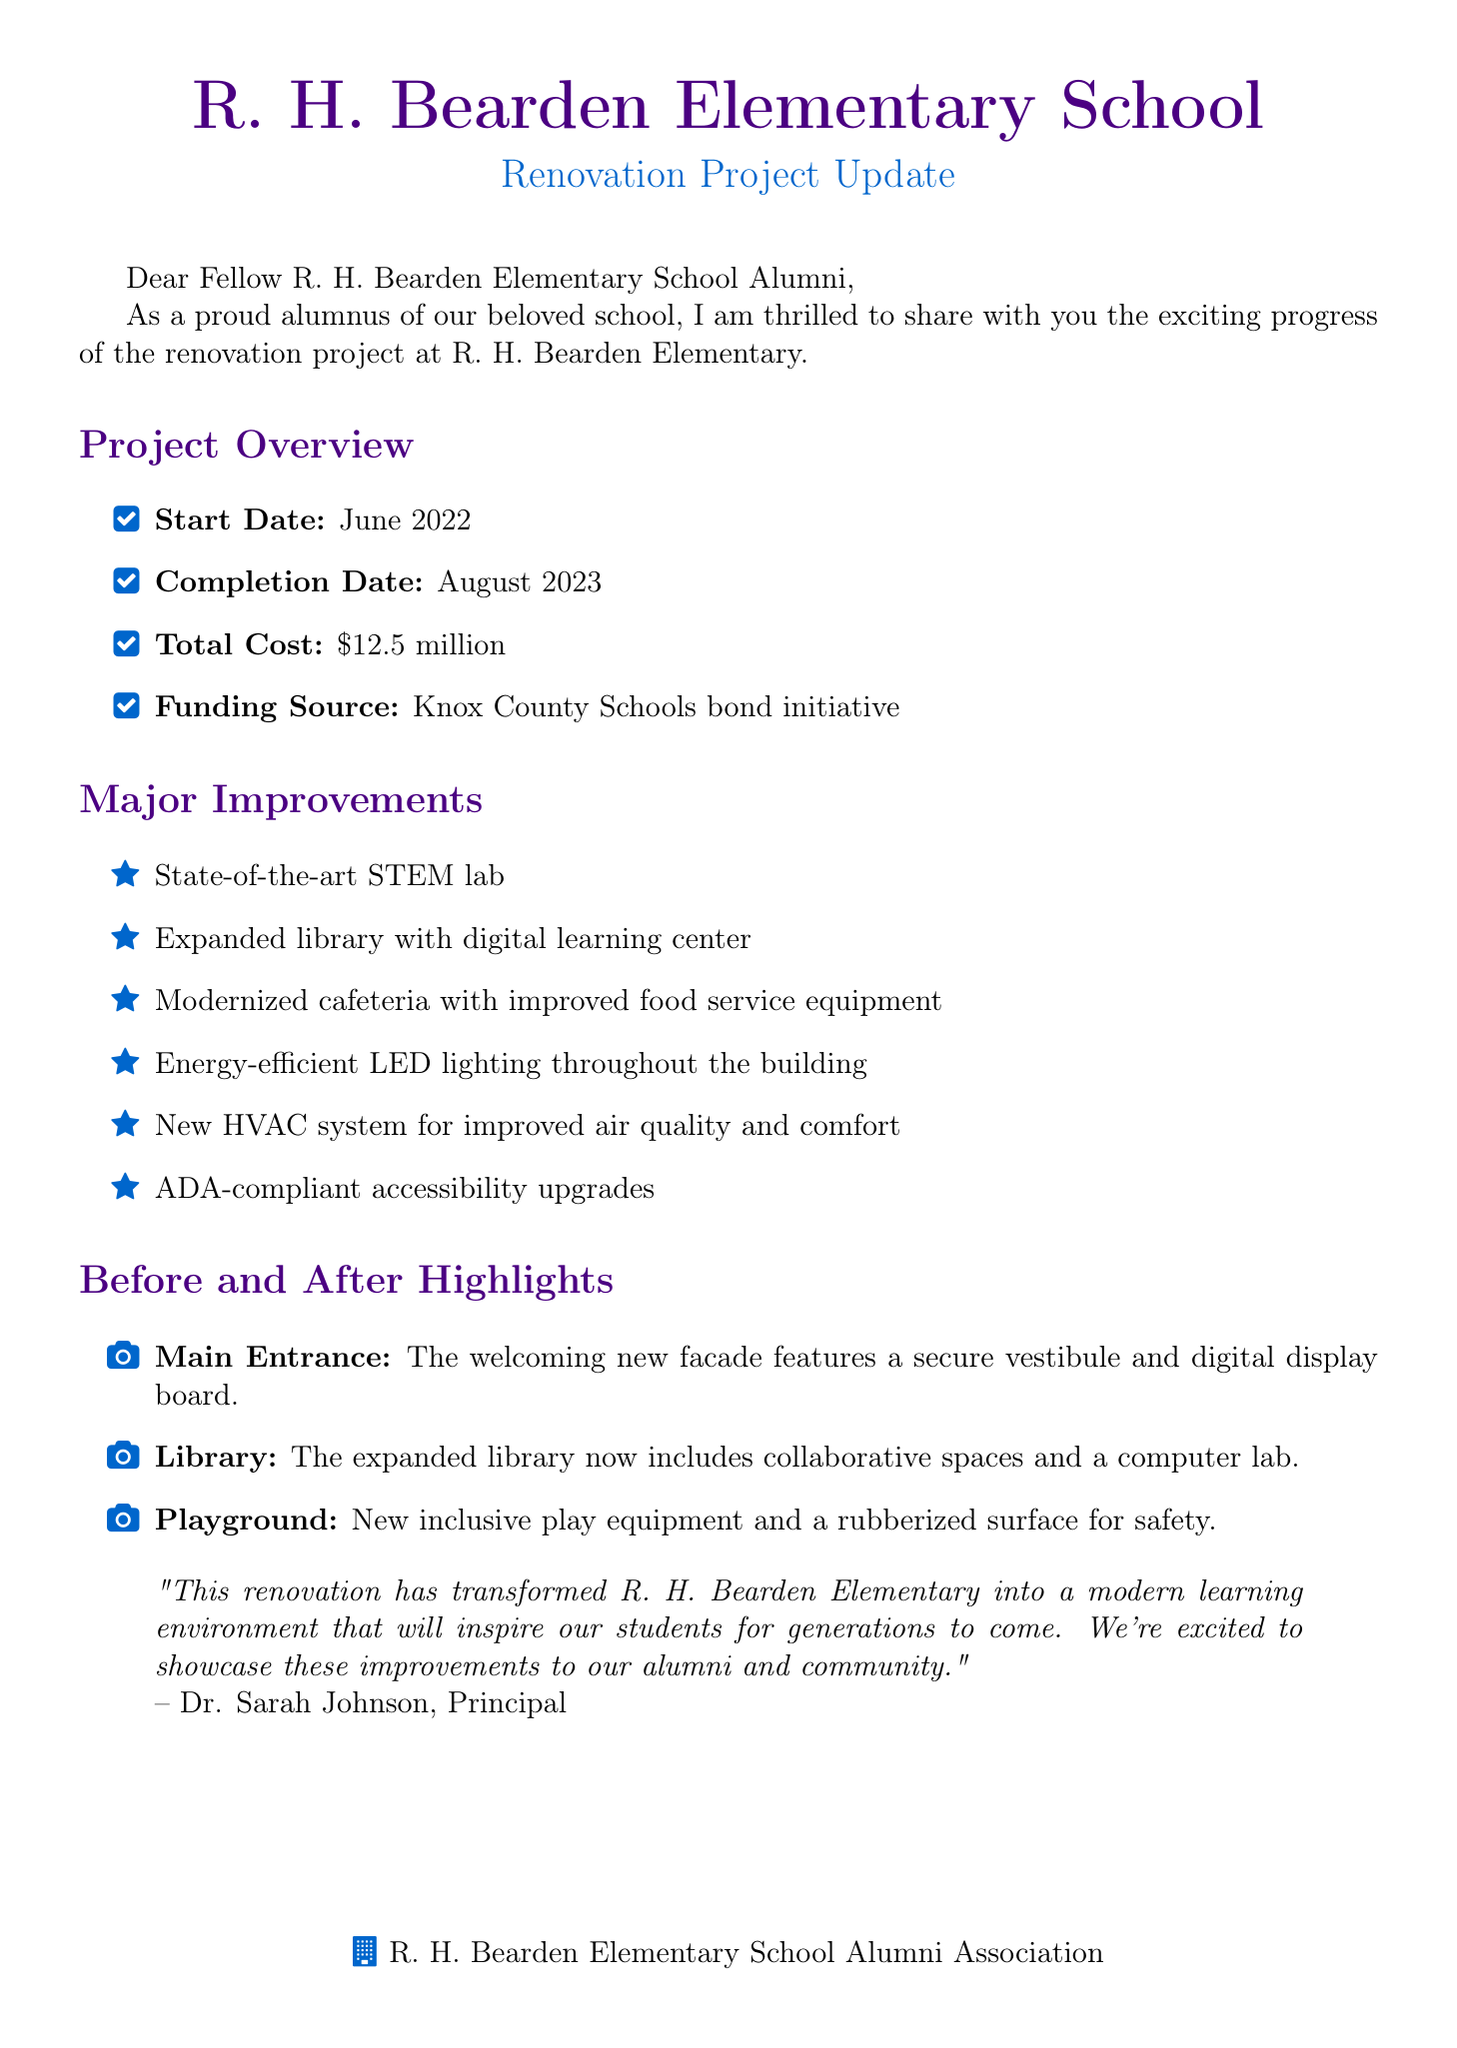What is the total cost of the renovation? The total cost of the renovation project is stated directly in the document.
Answer: $12.5 million When did the renovation project start? The start date of the renovation project is specifically mentioned in the document.
Answer: June 2022 What date is the Open House and Tour event scheduled for? The event date is highlighted in the invitation section of the document.
Answer: Saturday, September 16, 2023 Who is the principal quoted in the letter? The principal's name is provided in the quote section of the document.
Answer: Dr. Sarah Johnson What major improvement includes energy-efficient lighting? The section on major improvements lists all enhancements, including specific mentions of features.
Answer: Energy-efficient LED lighting throughout the building What activities are included in the invitation to the open house? The document lists various activities associated with the open house event.
Answer: Guided tours of the renovated facilities What is the name of the alumni association president? The document provides the name of the alumni association president in a specific message.
Answer: Michael Thompson How long did the renovation project take? The duration can be calculated from the start and completion dates in the project overview.
Answer: 14 months What type of new lab was included in the renovations? The document specifically mentions the types of improvements made, including the type of lab.
Answer: State-of-the-art STEM lab 